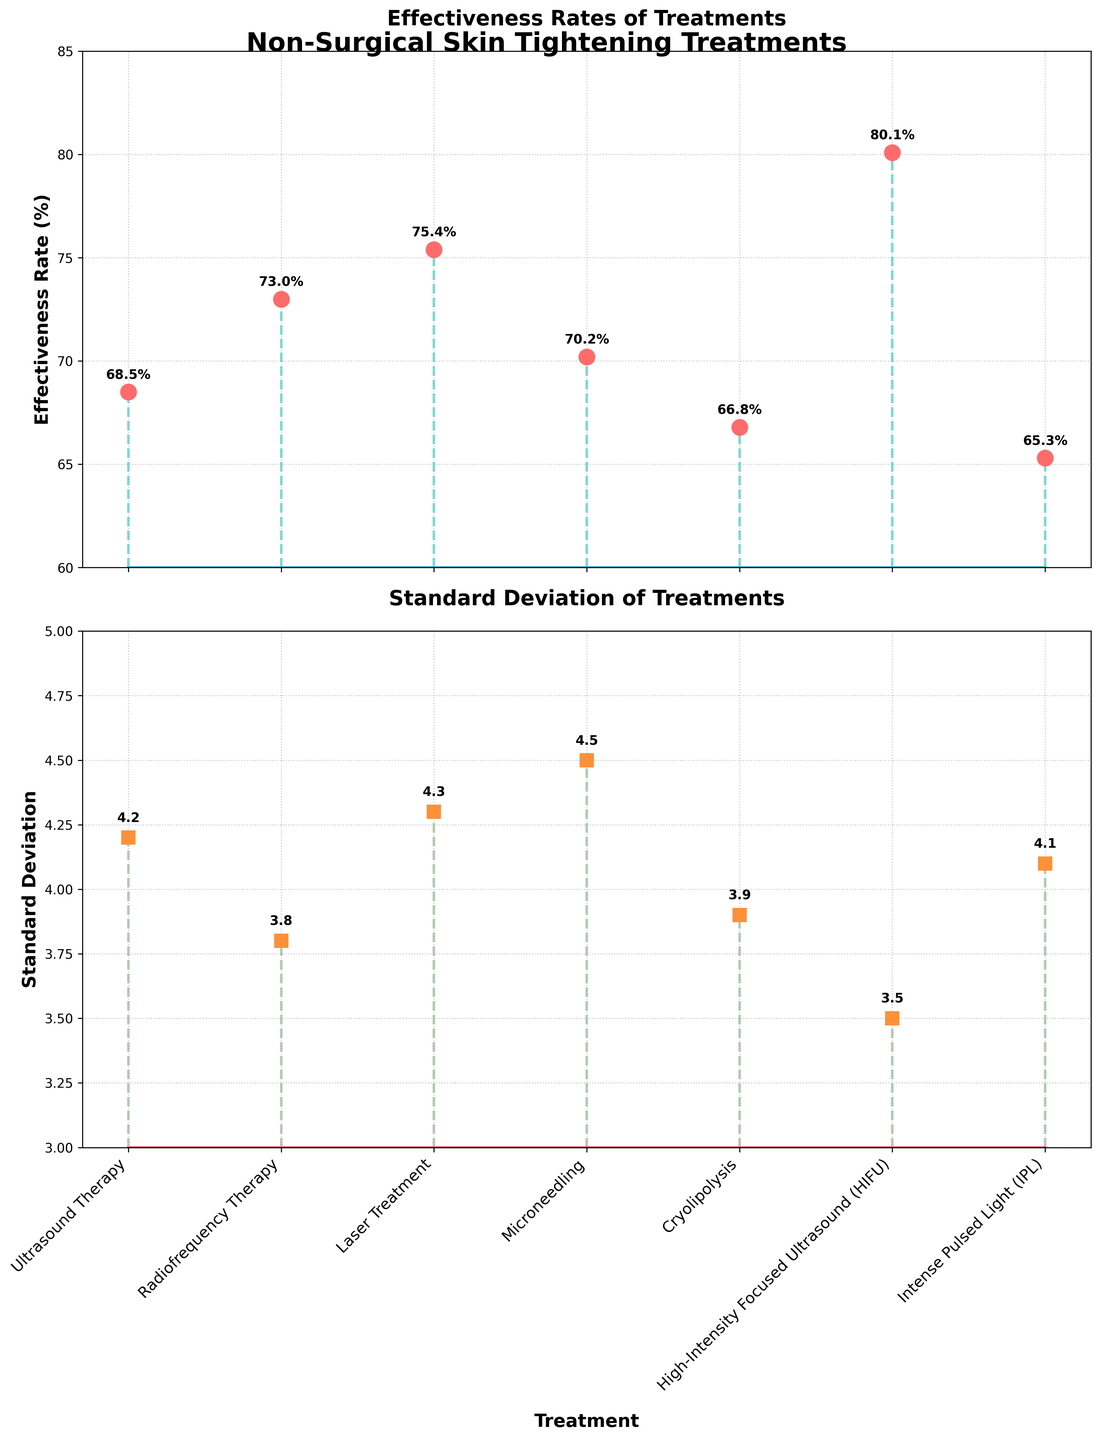What is the highest effectiveness rate reported in the figure? The highest effectiveness rate can be identified by looking at the stem plot where the effectiveness rate is plotted. The tallest stem represents the highest rate.
Answer: 80.1% What is the treatment associated with the lowest standard deviation? To find this, examine the standard deviation subplot and look for the shortest stem. This indicates the lowest value. The corresponding treatment label identifies the treatment.
Answer: High-Intensity Focused Ultrasound (HIFU) Which treatment has a higher effectiveness rate: Ultrasound Therapy or Intense Pulsed Light (IPL)? Compare the heights of the stems corresponding to these two treatments in the effectiveness rate subplot. Identify which one is taller.
Answer: Ultrasound Therapy What is the average effectiveness rate of all treatments? To calculate the average, sum up all effectiveness rates: (68.5 + 73.0 + 75.4 + 70.2 + 66.8 + 80.1 + 65.3). Then divide by the number of treatments (7). (499.3 / 7)
Answer: 71.33% Which treatment has the most consistent effectiveness rate (lowest standard deviation)? Look at the standard deviation subplot and find the treatment with the lowest standard deviation. The consistency relates to lower variability.
Answer: High-Intensity Focused Ultrasound (HIFU) How does the effectiveness rate of Cryolipolysis compare to that of Microneedling? Compare the height of the stems for Cryolipolysis and Microneedling in the effectiveness rate subplot. Determine which is taller.
Answer: Microneedling is higher What's the difference between the highest and the lowest effectiveness rates among the treatments? Identify the highest effectiveness rate (80.1% for HIFU) and the lowest rate (65.3% for IPL). Subtract the lowest rate from the highest. (80.1 - 65.3)
Answer: 14.8% Which treatment's effectiveness rate is closest to the overall average rate? Calculate the average effectiveness rate (71.33%). Check which effectiveness rate value among the treatments is closest to this average.
Answer: Radiofrequency Therapy What color represents the stems in the effectiveness rate plot? Observe the color used for the stems representing effectiveness rates.
Answer: #4ECDC4 (Turquoise) Is there any treatment with an effectiveness rate below 70%? If so, which? Look at the stems in the effectiveness rate subplot and note any that fall below the 70% grid line. Identify the corresponding treatments.
Answer: Cryolipolysis, Intense Pulsed Light (IPL), Ultrasound Therapy 